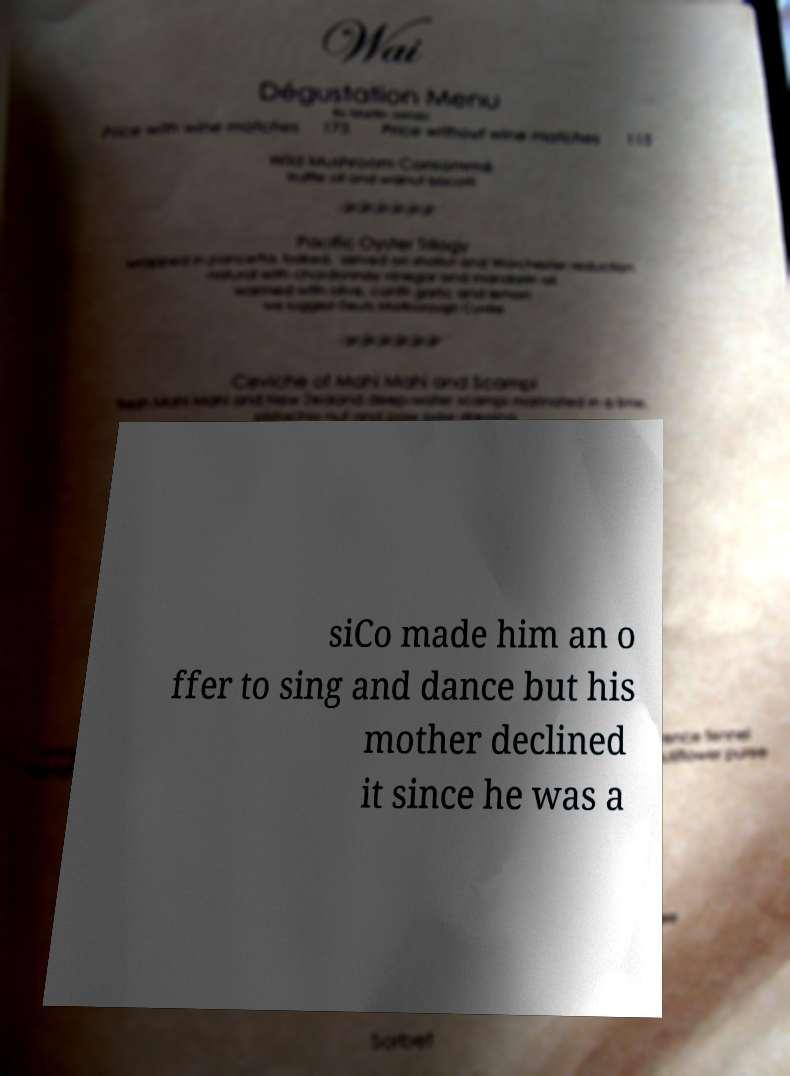For documentation purposes, I need the text within this image transcribed. Could you provide that? siCo made him an o ffer to sing and dance but his mother declined it since he was a 